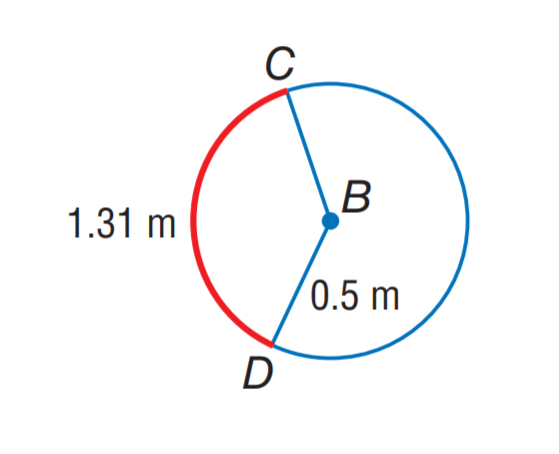Question: Find m \widehat C D.
Choices:
A. 120
B. 135
C. 150
D. 180
Answer with the letter. Answer: C 